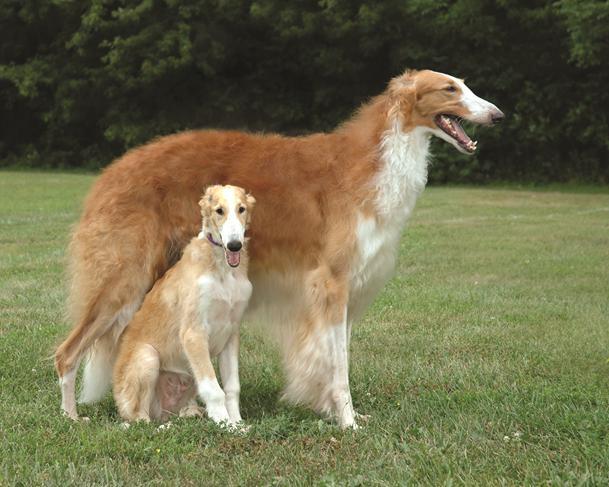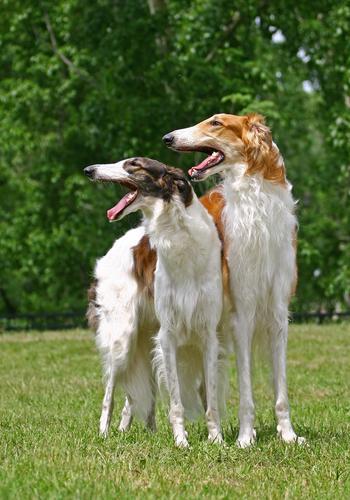The first image is the image on the left, the second image is the image on the right. For the images displayed, is the sentence "The dog in the image on the right is running across the grass to the right side." factually correct? Answer yes or no. No. The first image is the image on the left, the second image is the image on the right. Analyze the images presented: Is the assertion "In total, at least two dogs are bounding across a field with front paws off the ground." valid? Answer yes or no. No. 